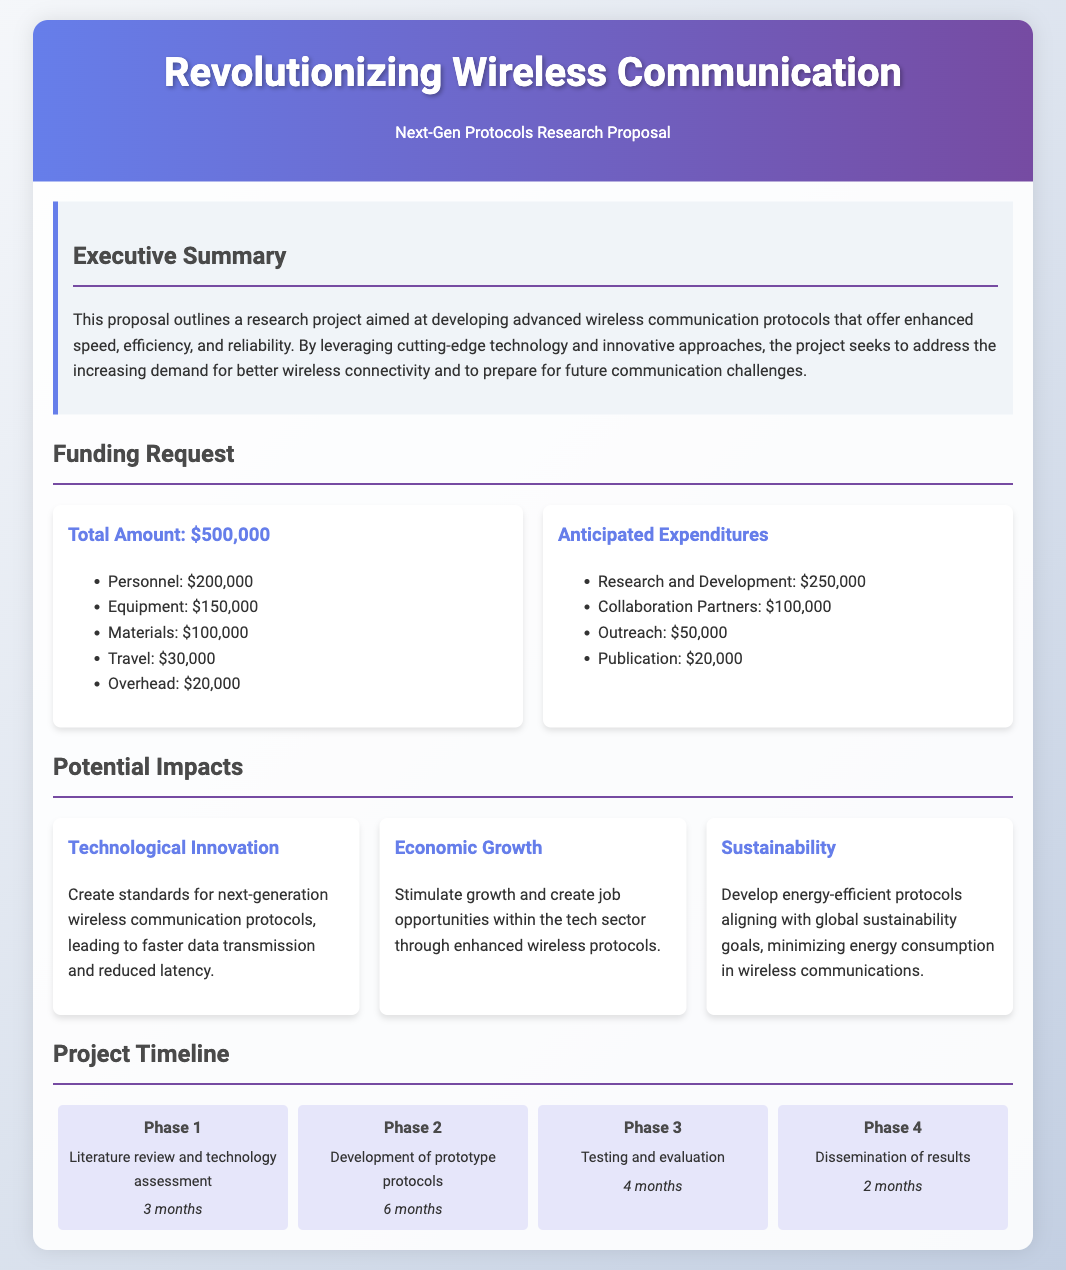what is the total funding request? The total funding request is stated in the funding request section and amounts to $500,000.
Answer: $500,000 how much is allocated for personnel? Personnel costs are detailed in the funding request section and amount to $200,000.
Answer: $200,000 what is the duration of Phase 2? The duration of Phase 2 is mentioned in the project timeline as 6 months for the development of prototype protocols.
Answer: 6 months name one potential impact of the project. Potential impacts are listed, one of which is "Technological Innovation," indicating advancements in wireless protocols.
Answer: Technological Innovation what is the anticipated expenditure for research and development? The document specifies that the anticipated expenditure for research and development is $250,000.
Answer: $250,000 how many phases are outlined in the project timeline? The project timeline consists of four distinct phases as mentioned in the document.
Answer: Four what is the budget for publication expenses? The publication budget is explicitly listed under anticipated expenditures as $20,000.
Answer: $20,000 state one goal related to sustainability. The document mentions the goal of developing "energy-efficient protocols" that align with global sustainability goals.
Answer: Energy-efficient protocols 